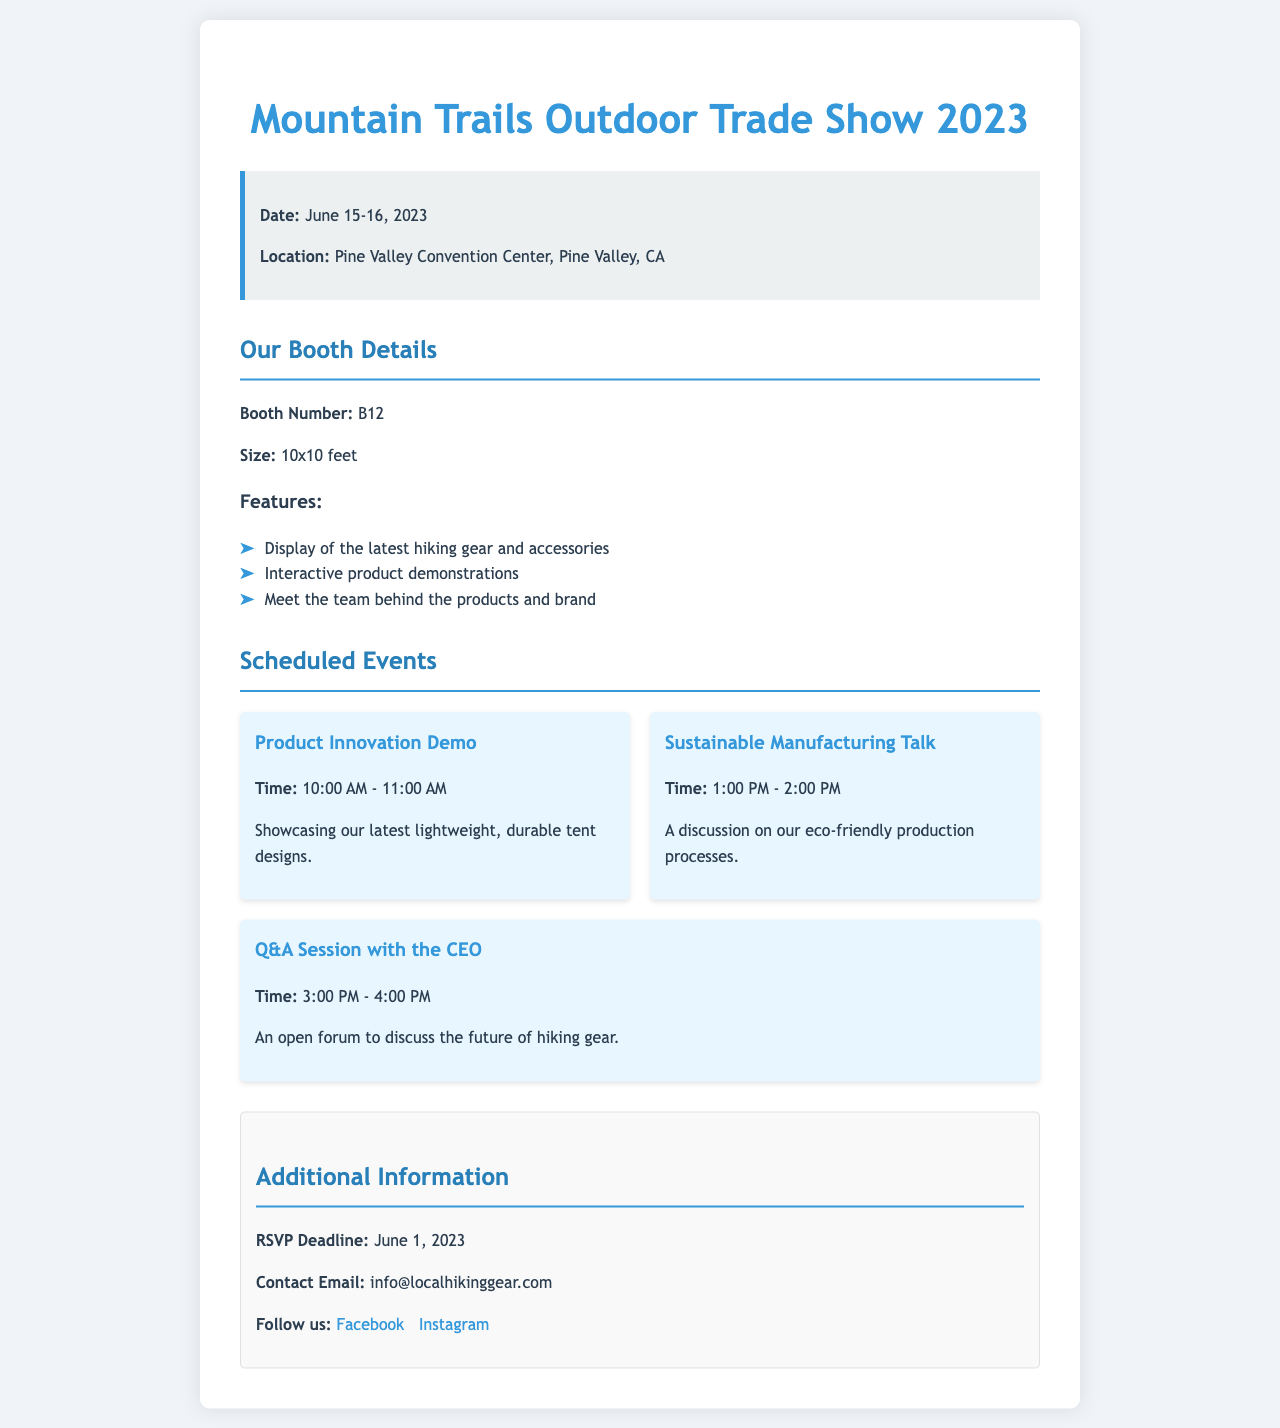what are the dates of the trade show? The dates of the trade show are explicitly stated in the document as June 15-16, 2023.
Answer: June 15-16, 2023 where is the trade show located? The location is provided in the document as the Pine Valley Convention Center, Pine Valley, CA.
Answer: Pine Valley Convention Center, Pine Valley, CA what is the booth number? The booth number is mentioned in the document, specifically as B12.
Answer: B12 how large is the booth? The document specifies the size of the booth as 10x10 feet.
Answer: 10x10 feet what time does the Product Innovation Demo start? The start time for the Product Innovation Demo is given in the schedule section as 10:00 AM.
Answer: 10:00 AM which event discusses eco-friendly processes? The event addressing eco-friendly processes is titled "Sustainable Manufacturing Talk."
Answer: Sustainable Manufacturing Talk how many scheduled events are there? The number of scheduled events can be counted from the document, with three events mentioned.
Answer: 3 what is the RSVP deadline? The RSVP deadline is stated in the additional information section as June 1, 2023.
Answer: June 1, 2023 what type of session is scheduled with the CEO? The scheduled session with the CEO is labeled as a Q&A Session.
Answer: Q&A Session 